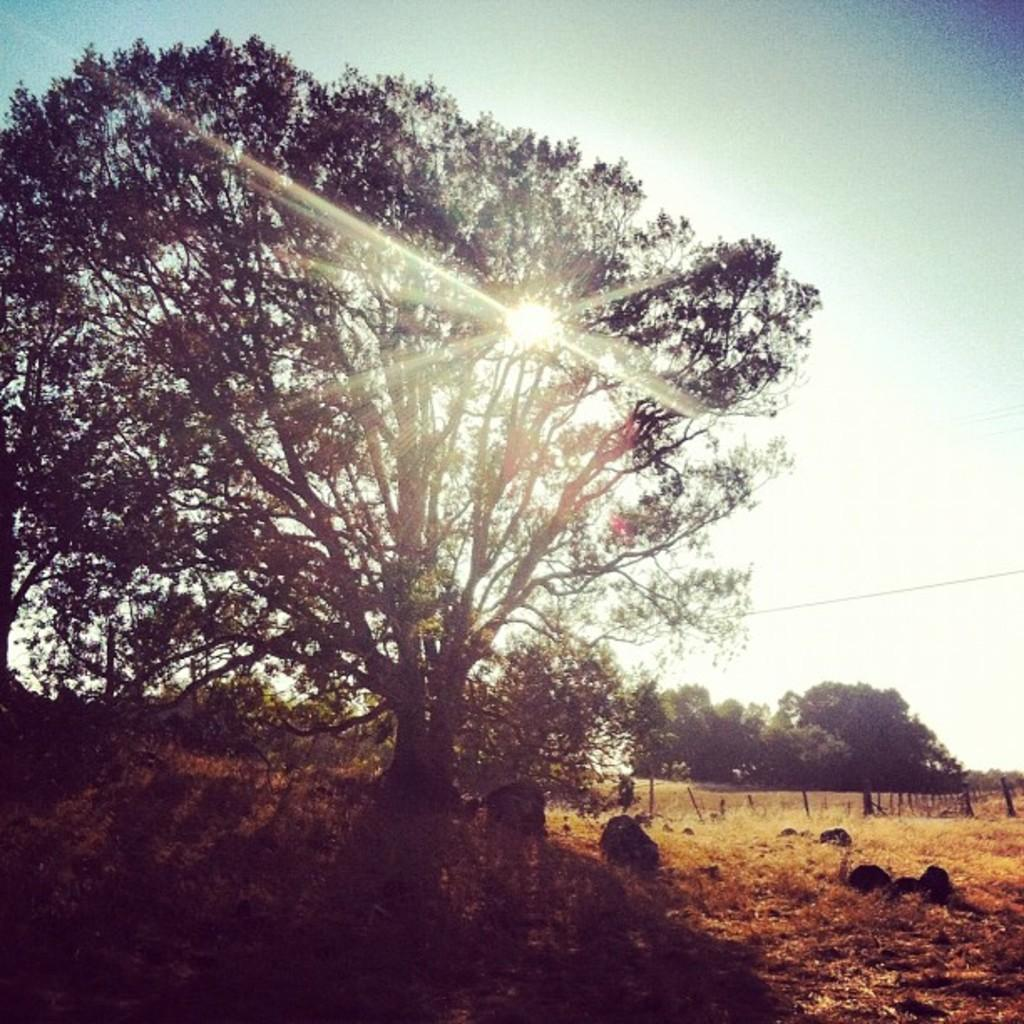What type of natural elements can be seen in the image? There are trees in the image. What can be observed coming from the sky in the image? Sun rays are visible in the image. What type of barrier is present in the image? There is a wooden fence in the image. What type of material is present on the ground in the image? Stones are present in the image. What color is the pet's leg in the image? There is no pet or leg present in the image. 